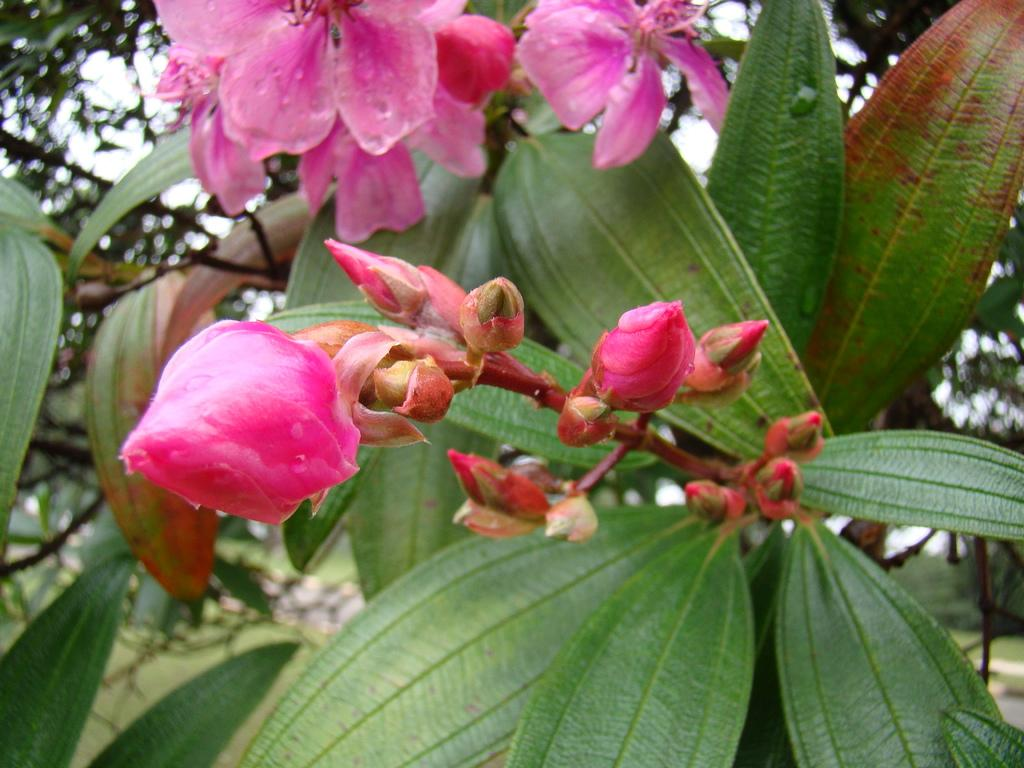What types of plant life can be seen in the foreground of the image? There are leaves, flowers, and buds in the foreground of the image. What else can be seen in the foreground of the image? There is there a stem? What is visible in the background of the image? There is a tree and the sky visible in the background of the image. What is the tax rate for the flowers in the image? There is no tax rate mentioned or implied in the image, as it is a photograph of plant life and not a representation of a taxable event. 